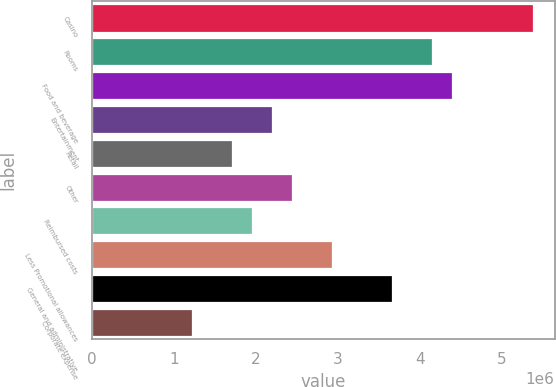Convert chart to OTSL. <chart><loc_0><loc_0><loc_500><loc_500><bar_chart><fcel>Casino<fcel>Rooms<fcel>Food and beverage<fcel>Entertainment<fcel>Retail<fcel>Other<fcel>Reimbursed costs<fcel>Less Promotional allowances<fcel>General and administrative<fcel>Corporate expense<nl><fcel>5.37444e+06<fcel>4.15297e+06<fcel>4.39727e+06<fcel>2.19863e+06<fcel>1.71005e+06<fcel>2.44293e+06<fcel>1.95434e+06<fcel>2.93151e+06<fcel>3.66439e+06<fcel>1.22147e+06<nl></chart> 